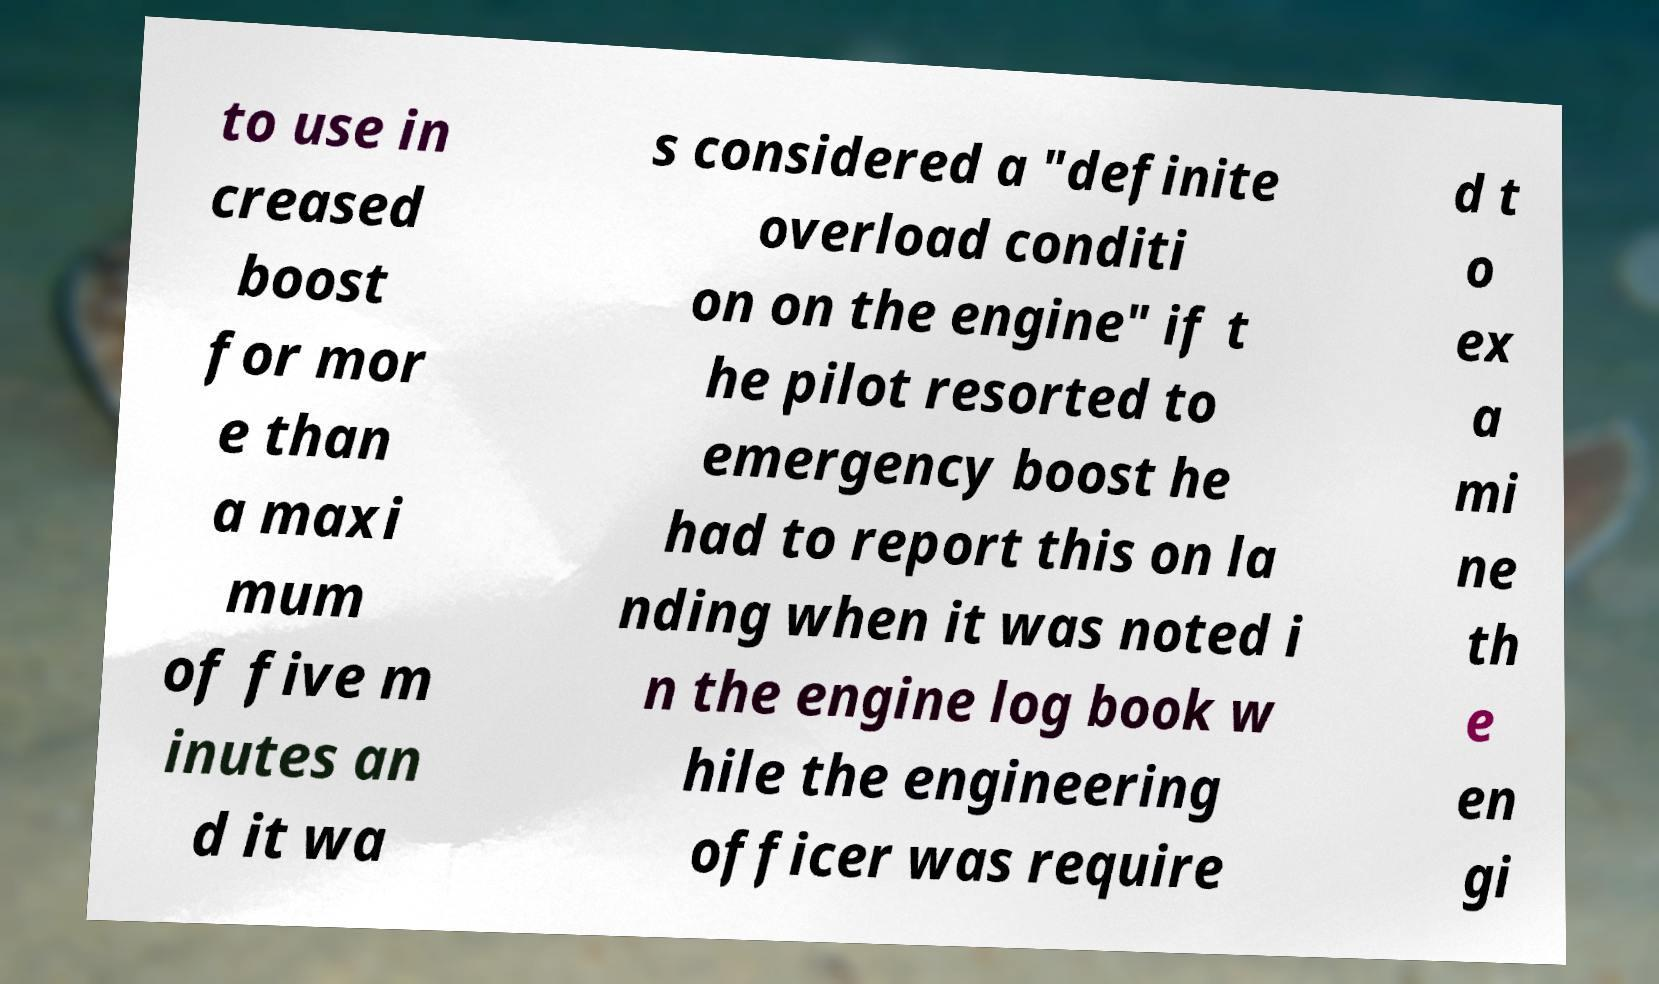Please read and relay the text visible in this image. What does it say? to use in creased boost for mor e than a maxi mum of five m inutes an d it wa s considered a "definite overload conditi on on the engine" if t he pilot resorted to emergency boost he had to report this on la nding when it was noted i n the engine log book w hile the engineering officer was require d t o ex a mi ne th e en gi 